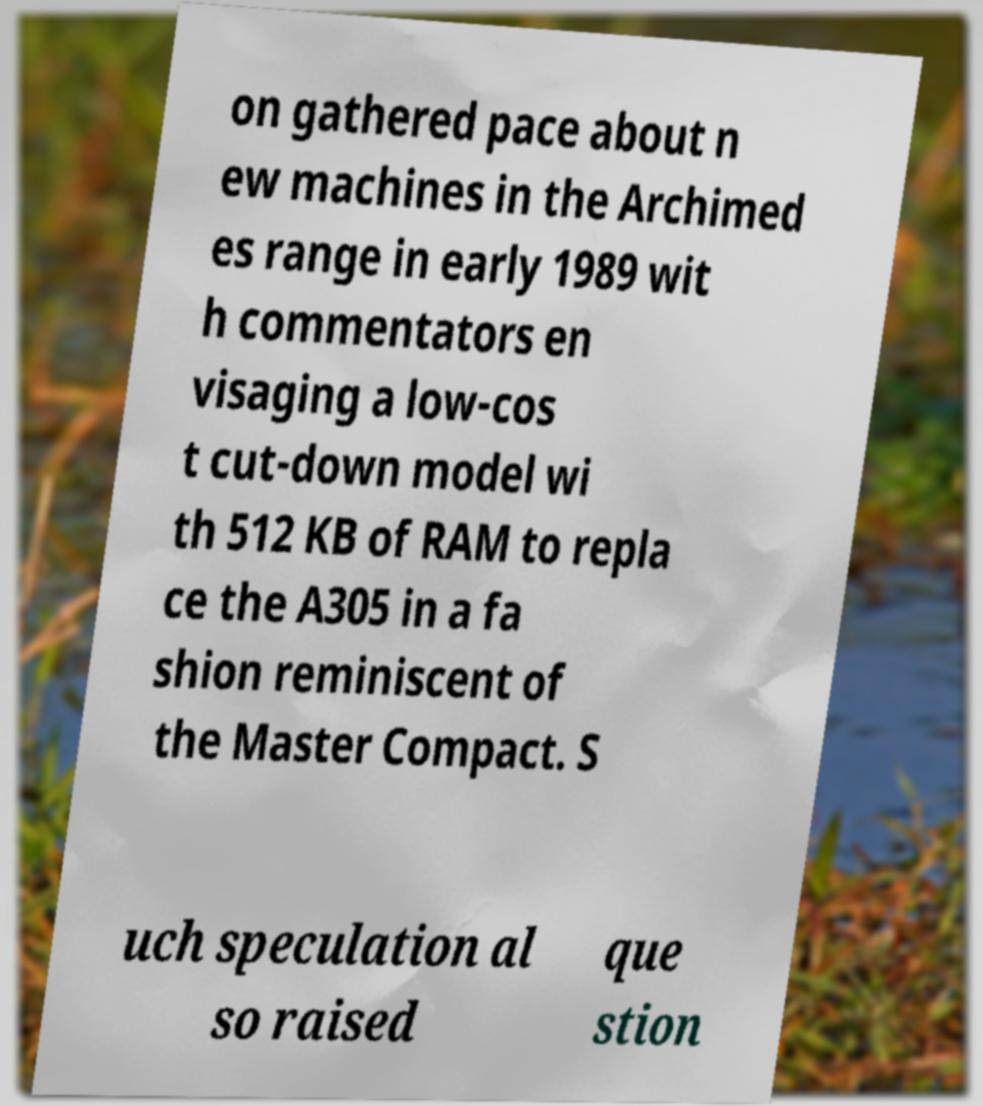What messages or text are displayed in this image? I need them in a readable, typed format. on gathered pace about n ew machines in the Archimed es range in early 1989 wit h commentators en visaging a low-cos t cut-down model wi th 512 KB of RAM to repla ce the A305 in a fa shion reminiscent of the Master Compact. S uch speculation al so raised que stion 